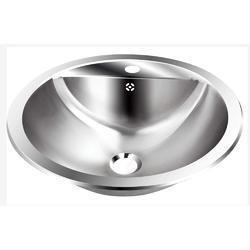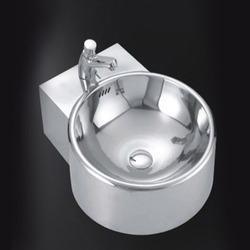The first image is the image on the left, the second image is the image on the right. Evaluate the accuracy of this statement regarding the images: "An image shows a long sink unit with at least three faucets.". Is it true? Answer yes or no. No. 